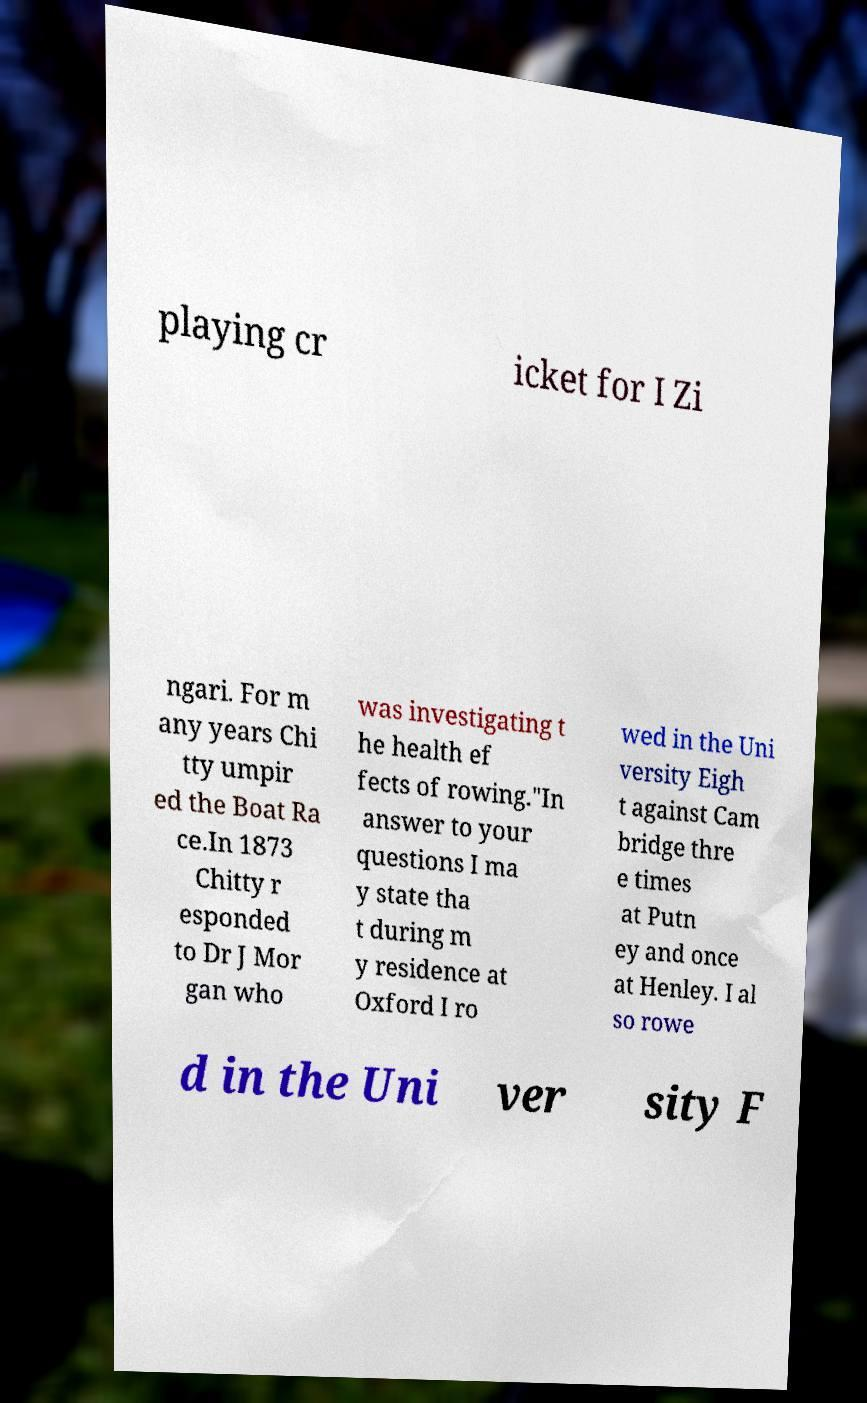Could you assist in decoding the text presented in this image and type it out clearly? playing cr icket for I Zi ngari. For m any years Chi tty umpir ed the Boat Ra ce.In 1873 Chitty r esponded to Dr J Mor gan who was investigating t he health ef fects of rowing."In answer to your questions I ma y state tha t during m y residence at Oxford I ro wed in the Uni versity Eigh t against Cam bridge thre e times at Putn ey and once at Henley. I al so rowe d in the Uni ver sity F 